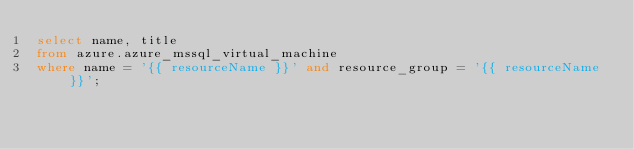Convert code to text. <code><loc_0><loc_0><loc_500><loc_500><_SQL_>select name, title
from azure.azure_mssql_virtual_machine
where name = '{{ resourceName }}' and resource_group = '{{ resourceName }}';
</code> 